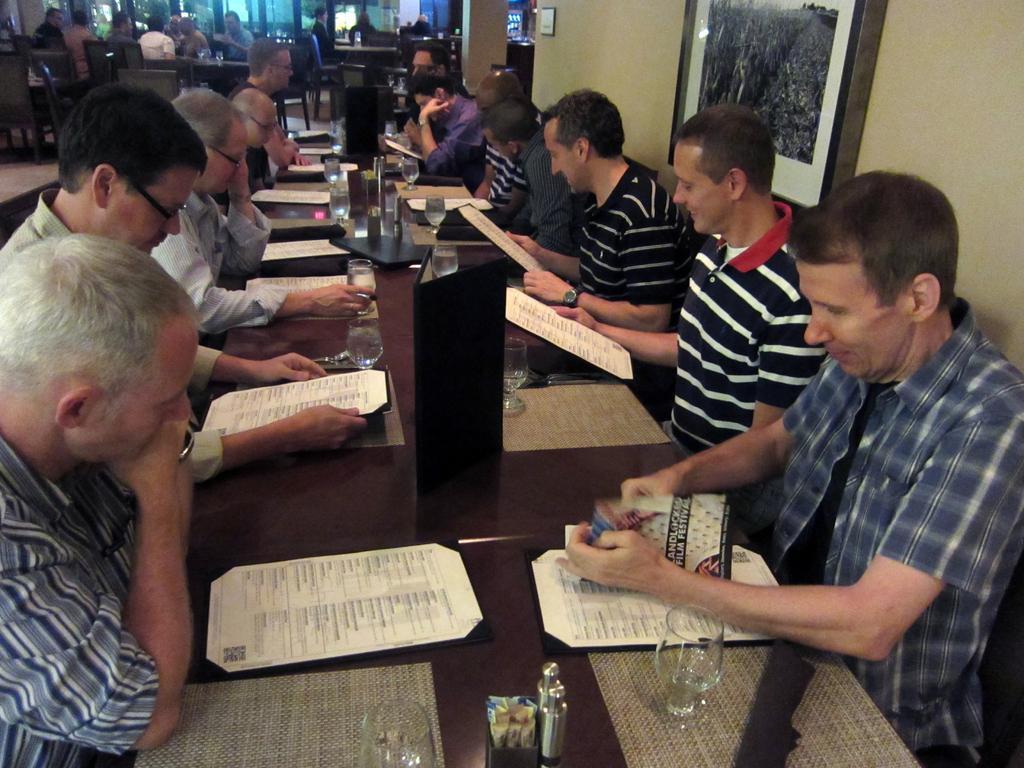Can you describe this image briefly? In this image i can see a group of people are sitting in front of a table. On the table we have few objects on it. 